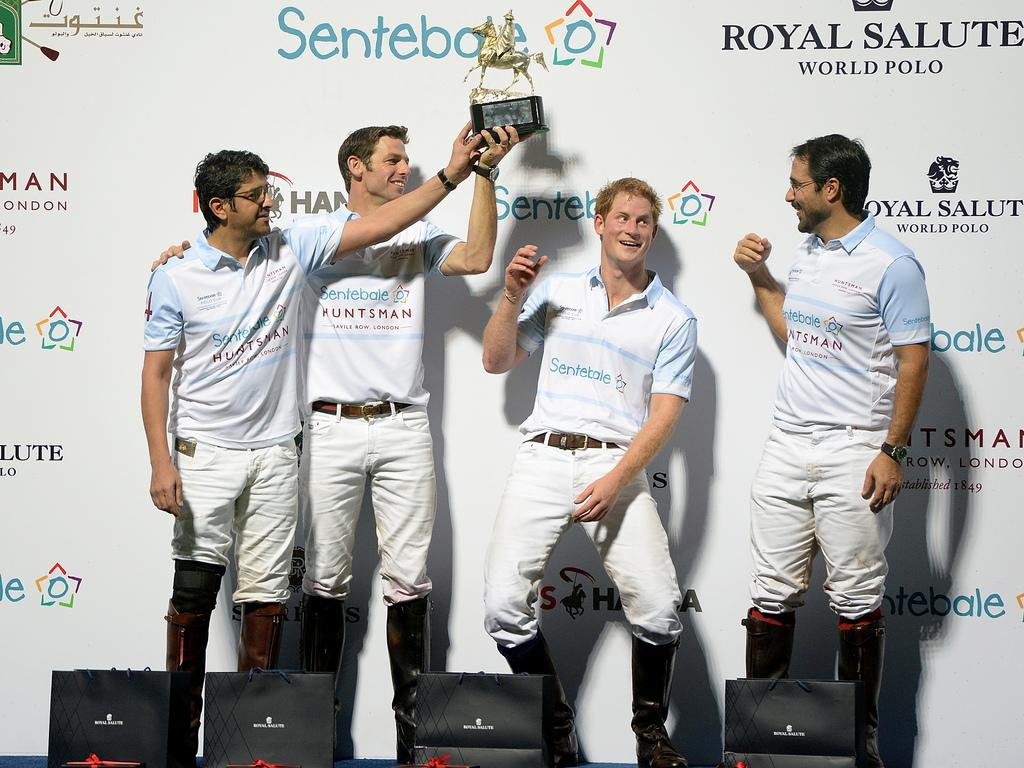<image>
Present a compact description of the photo's key features. Four men stand with a trophy in front of a wall that says Royal Salute World Polo. 